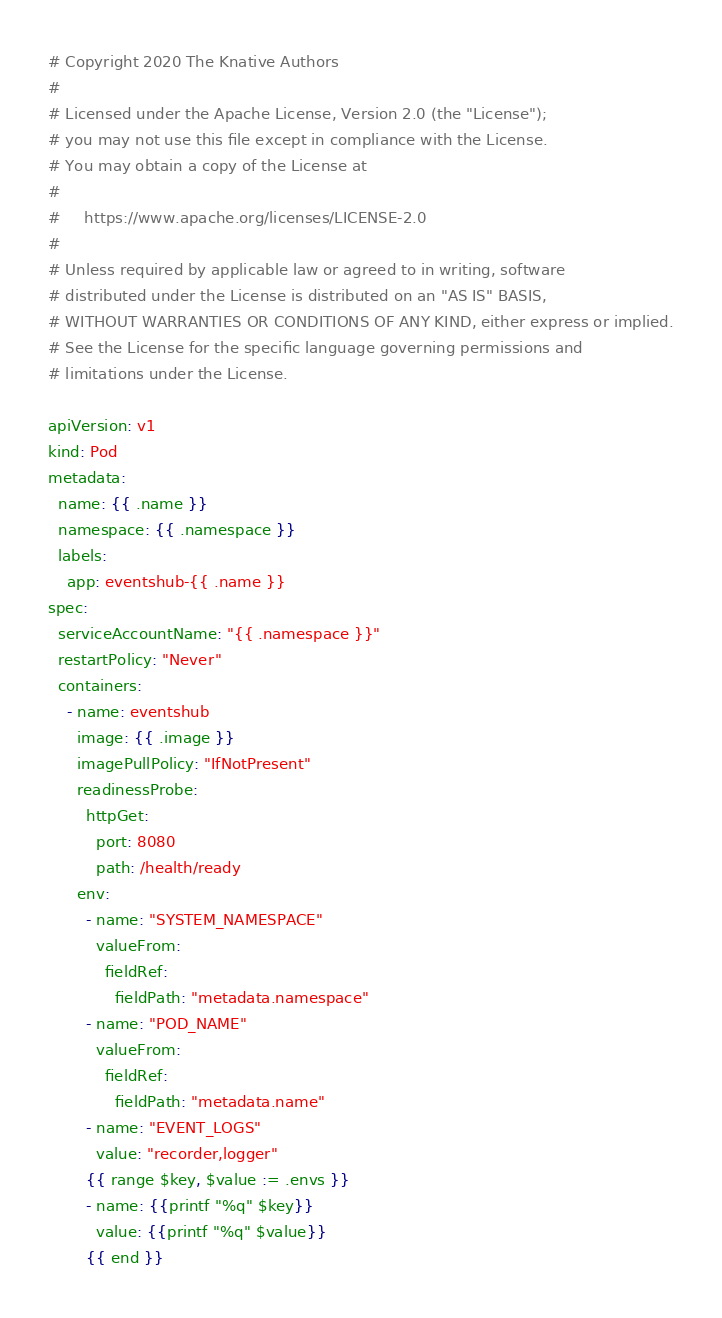Convert code to text. <code><loc_0><loc_0><loc_500><loc_500><_YAML_># Copyright 2020 The Knative Authors
#
# Licensed under the Apache License, Version 2.0 (the "License");
# you may not use this file except in compliance with the License.
# You may obtain a copy of the License at
#
#     https://www.apache.org/licenses/LICENSE-2.0
#
# Unless required by applicable law or agreed to in writing, software
# distributed under the License is distributed on an "AS IS" BASIS,
# WITHOUT WARRANTIES OR CONDITIONS OF ANY KIND, either express or implied.
# See the License for the specific language governing permissions and
# limitations under the License.

apiVersion: v1
kind: Pod
metadata:
  name: {{ .name }}
  namespace: {{ .namespace }}
  labels:
    app: eventshub-{{ .name }}
spec:
  serviceAccountName: "{{ .namespace }}"
  restartPolicy: "Never"
  containers:
    - name: eventshub
      image: {{ .image }}
      imagePullPolicy: "IfNotPresent"
      readinessProbe:
        httpGet:
          port: 8080
          path: /health/ready
      env:
        - name: "SYSTEM_NAMESPACE"
          valueFrom:
            fieldRef:
              fieldPath: "metadata.namespace"
        - name: "POD_NAME"
          valueFrom:
            fieldRef:
              fieldPath: "metadata.name"
        - name: "EVENT_LOGS"
          value: "recorder,logger"
        {{ range $key, $value := .envs }}
        - name: {{printf "%q" $key}}
          value: {{printf "%q" $value}}
        {{ end }}
</code> 